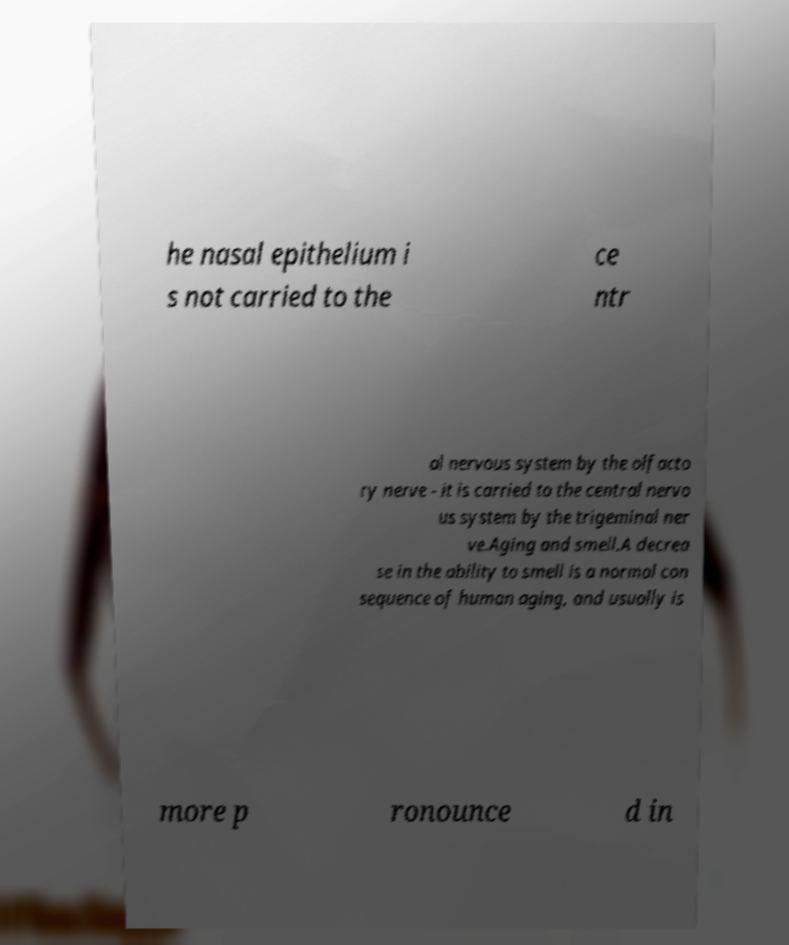Could you extract and type out the text from this image? he nasal epithelium i s not carried to the ce ntr al nervous system by the olfacto ry nerve - it is carried to the central nervo us system by the trigeminal ner ve.Aging and smell.A decrea se in the ability to smell is a normal con sequence of human aging, and usually is more p ronounce d in 